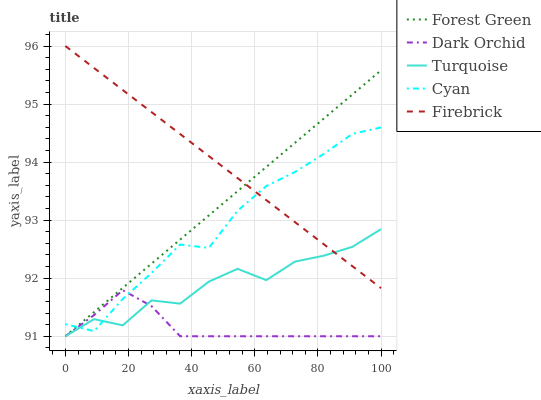Does Dark Orchid have the minimum area under the curve?
Answer yes or no. Yes. Does Firebrick have the maximum area under the curve?
Answer yes or no. Yes. Does Forest Green have the minimum area under the curve?
Answer yes or no. No. Does Forest Green have the maximum area under the curve?
Answer yes or no. No. Is Firebrick the smoothest?
Answer yes or no. Yes. Is Turquoise the roughest?
Answer yes or no. Yes. Is Forest Green the smoothest?
Answer yes or no. No. Is Forest Green the roughest?
Answer yes or no. No. Does Forest Green have the lowest value?
Answer yes or no. Yes. Does Firebrick have the lowest value?
Answer yes or no. No. Does Firebrick have the highest value?
Answer yes or no. Yes. Does Forest Green have the highest value?
Answer yes or no. No. Is Dark Orchid less than Firebrick?
Answer yes or no. Yes. Is Firebrick greater than Dark Orchid?
Answer yes or no. Yes. Does Forest Green intersect Cyan?
Answer yes or no. Yes. Is Forest Green less than Cyan?
Answer yes or no. No. Is Forest Green greater than Cyan?
Answer yes or no. No. Does Dark Orchid intersect Firebrick?
Answer yes or no. No. 